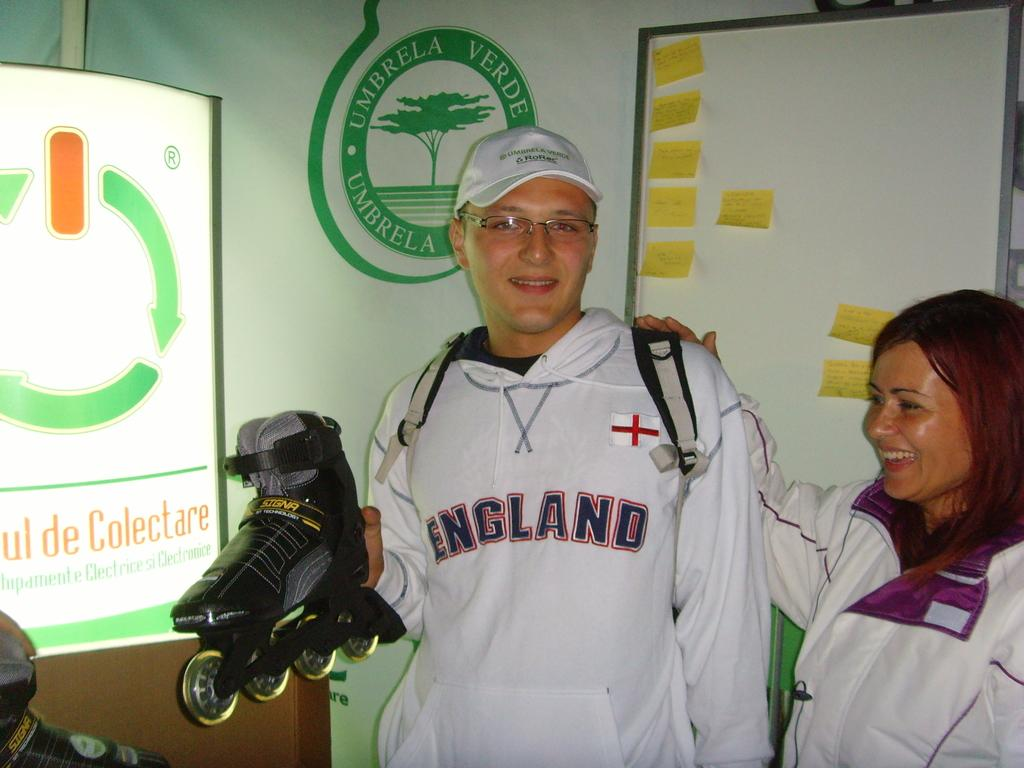<image>
Render a clear and concise summary of the photo. A man in an England sweatshirt is holding up a roller-blade. 